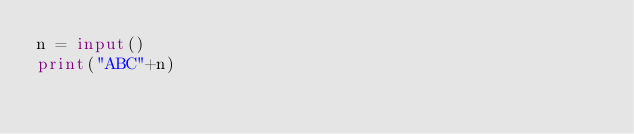<code> <loc_0><loc_0><loc_500><loc_500><_Python_>n = input()
print("ABC"+n)
</code> 